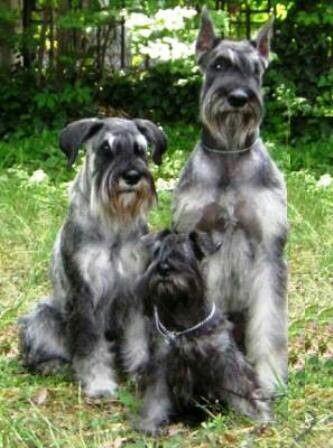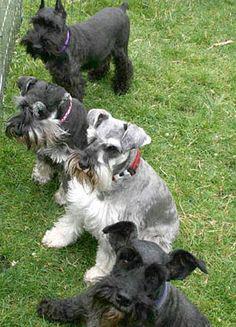The first image is the image on the left, the second image is the image on the right. Examine the images to the left and right. Is the description "There are no more than four dogs" accurate? Answer yes or no. No. 